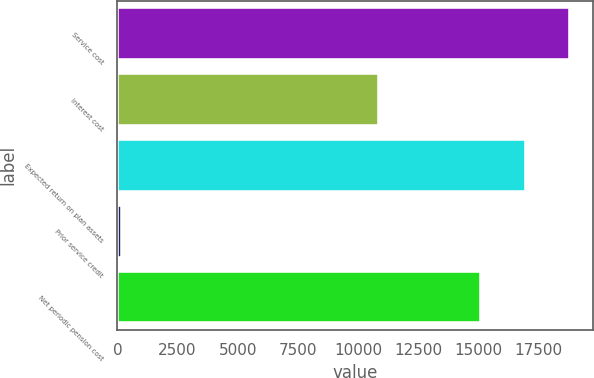Convert chart to OTSL. <chart><loc_0><loc_0><loc_500><loc_500><bar_chart><fcel>Service cost<fcel>Interest cost<fcel>Expected return on plan assets<fcel>Prior service credit<fcel>Net periodic pension cost<nl><fcel>18818.6<fcel>10869<fcel>16979.3<fcel>206<fcel>15140<nl></chart> 